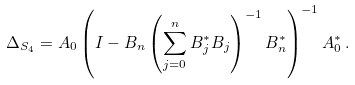<formula> <loc_0><loc_0><loc_500><loc_500>\Delta _ { S _ { 4 } } = A _ { 0 } \left ( I - B _ { n } \left ( \sum _ { j = 0 } ^ { n } B _ { j } ^ { * } B _ { j } \right ) ^ { - 1 } B _ { n } ^ { * } \right ) ^ { - 1 } A _ { 0 } ^ { * } \, .</formula> 